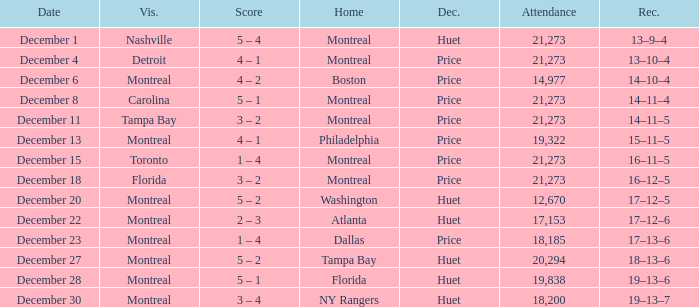Could you parse the entire table as a dict? {'header': ['Date', 'Vis.', 'Score', 'Home', 'Dec.', 'Attendance', 'Rec.'], 'rows': [['December 1', 'Nashville', '5 – 4', 'Montreal', 'Huet', '21,273', '13–9–4'], ['December 4', 'Detroit', '4 – 1', 'Montreal', 'Price', '21,273', '13–10–4'], ['December 6', 'Montreal', '4 – 2', 'Boston', 'Price', '14,977', '14–10–4'], ['December 8', 'Carolina', '5 – 1', 'Montreal', 'Price', '21,273', '14–11–4'], ['December 11', 'Tampa Bay', '3 – 2', 'Montreal', 'Price', '21,273', '14–11–5'], ['December 13', 'Montreal', '4 – 1', 'Philadelphia', 'Price', '19,322', '15–11–5'], ['December 15', 'Toronto', '1 – 4', 'Montreal', 'Price', '21,273', '16–11–5'], ['December 18', 'Florida', '3 – 2', 'Montreal', 'Price', '21,273', '16–12–5'], ['December 20', 'Montreal', '5 – 2', 'Washington', 'Huet', '12,670', '17–12–5'], ['December 22', 'Montreal', '2 – 3', 'Atlanta', 'Huet', '17,153', '17–12–6'], ['December 23', 'Montreal', '1 – 4', 'Dallas', 'Price', '18,185', '17–13–6'], ['December 27', 'Montreal', '5 – 2', 'Tampa Bay', 'Huet', '20,294', '18–13–6'], ['December 28', 'Montreal', '5 – 1', 'Florida', 'Huet', '19,838', '19–13–6'], ['December 30', 'Montreal', '3 – 4', 'NY Rangers', 'Huet', '18,200', '19–13–7']]} What is the score when Philadelphia is at home? 4 – 1. 